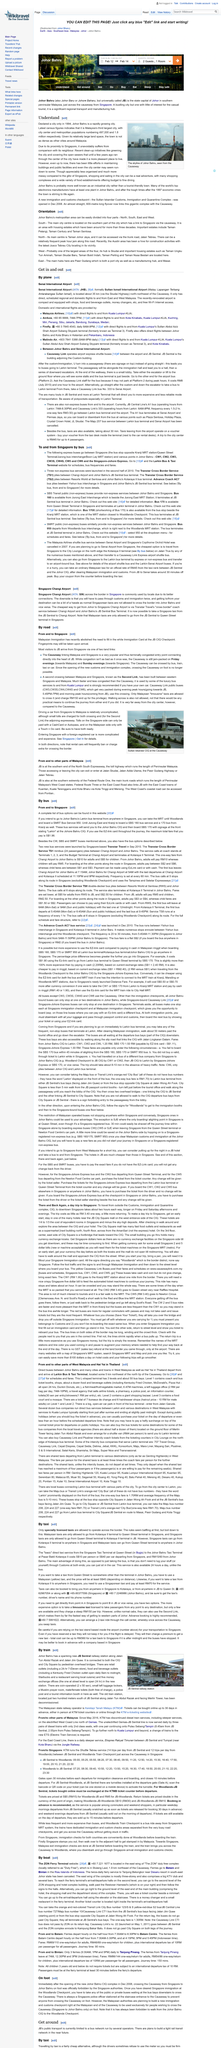Identify some key points in this picture. According to available data, the metropolitan population in Johor Bahru is estimated to be approximately 1.8 million. Yes, there are budget dining options available in Johor Bahru that range from budget to fine dining. Johor Bahru offers a range of exciting activities for visitors, including shopping and dining. The city is home to numerous shopping complexes and a diverse selection of food establishments, providing ample opportunities for shopping and eating enthusiasts to indulge in their passions. Whether you prefer to browse the latest fashion trends or sample local cuisine, Johor Bahru has something to offer for everyone. 